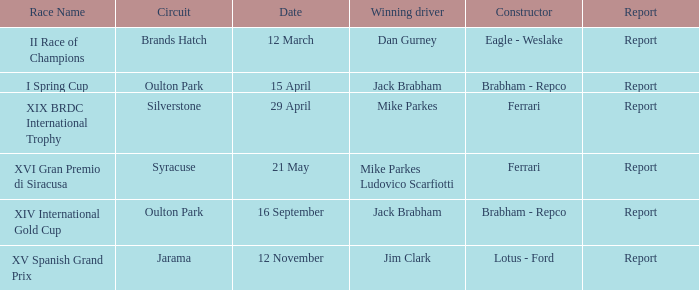On april 15th, what is the circuit being held? Oulton Park. 